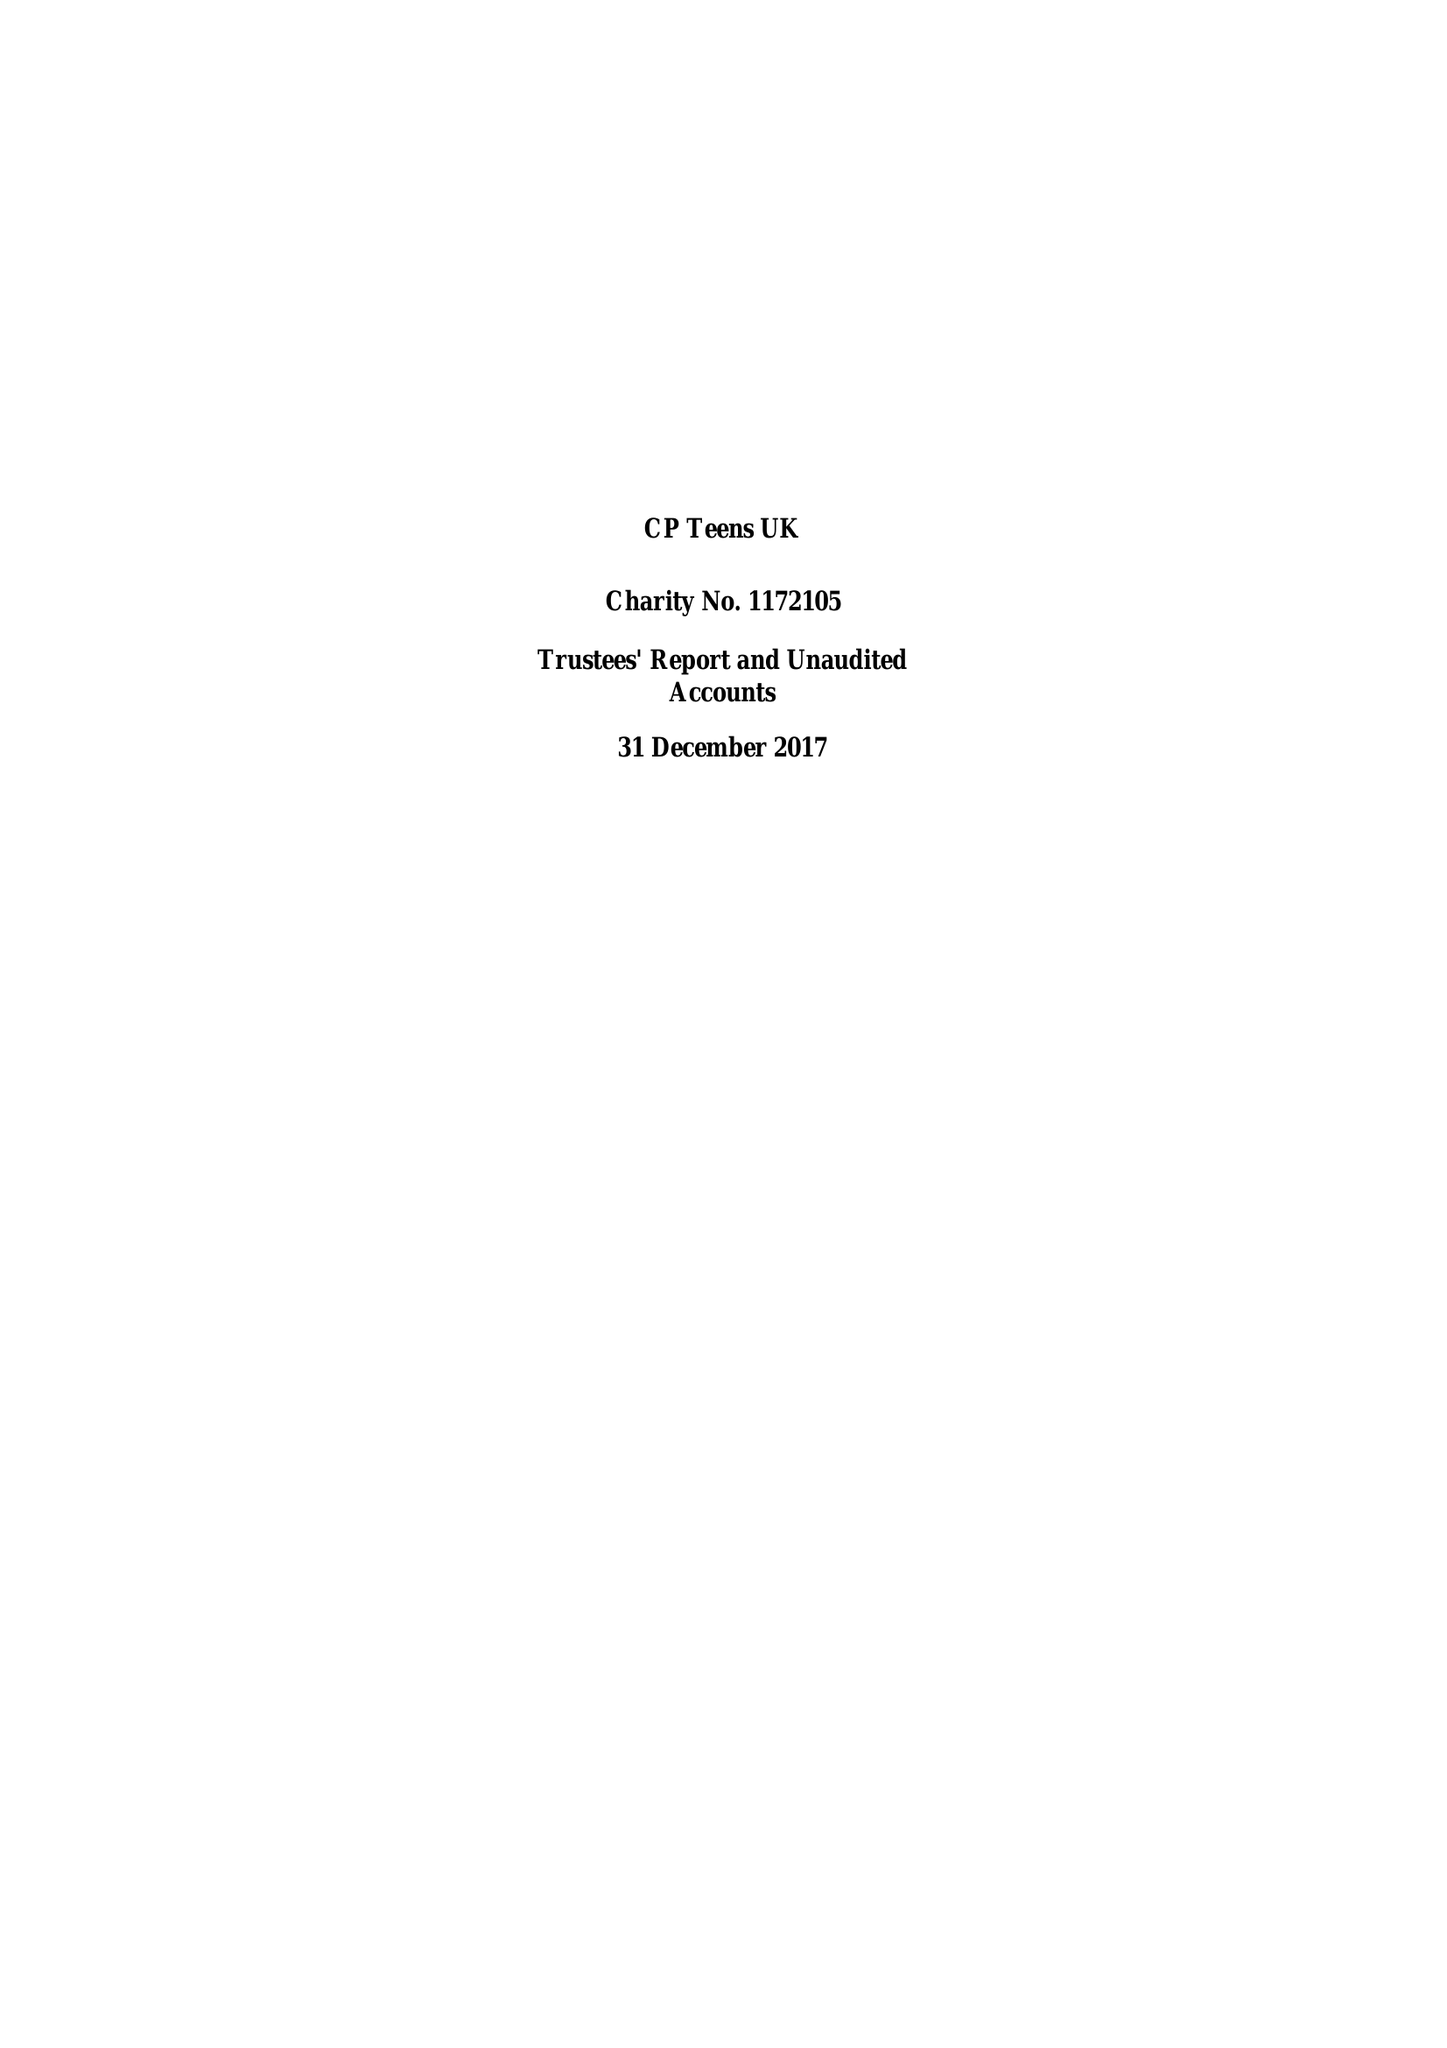What is the value for the address__postcode?
Answer the question using a single word or phrase. S42 7NS 